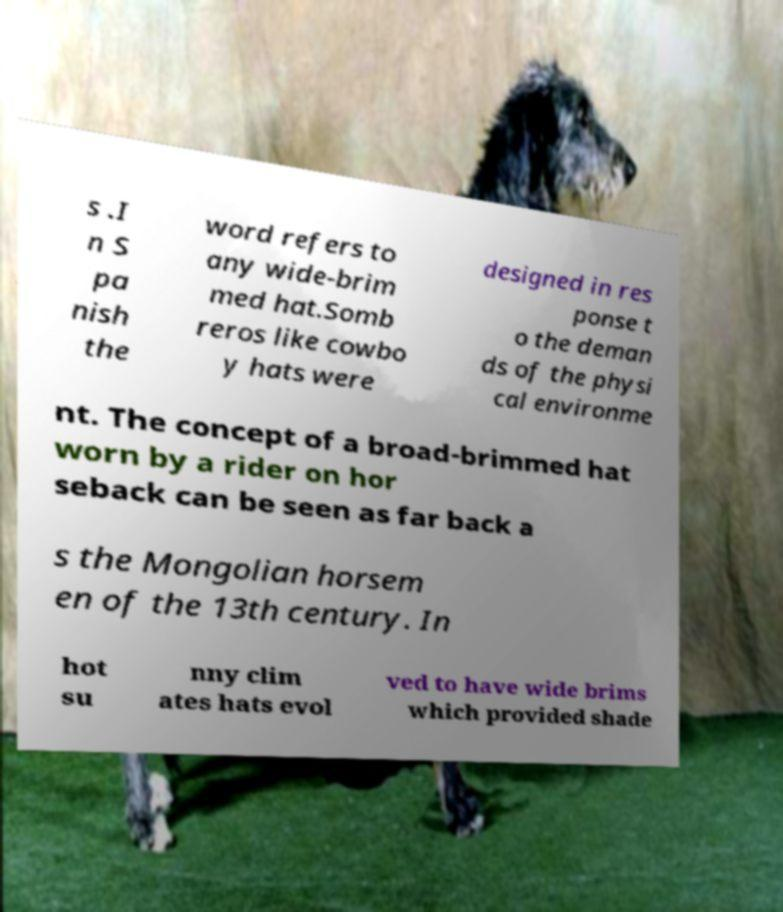For documentation purposes, I need the text within this image transcribed. Could you provide that? s .I n S pa nish the word refers to any wide-brim med hat.Somb reros like cowbo y hats were designed in res ponse t o the deman ds of the physi cal environme nt. The concept of a broad-brimmed hat worn by a rider on hor seback can be seen as far back a s the Mongolian horsem en of the 13th century. In hot su nny clim ates hats evol ved to have wide brims which provided shade 